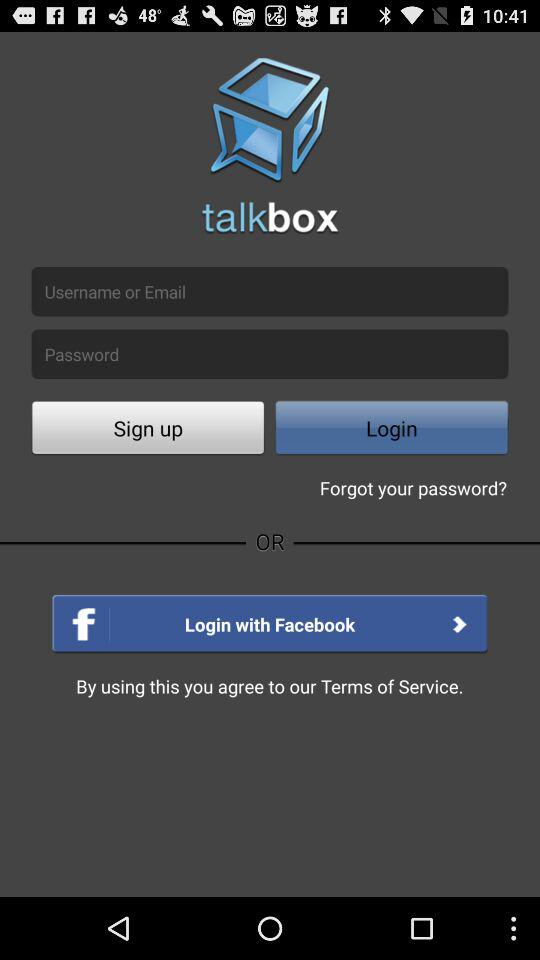What is the name of the application? The name of the application is "talkbox". 